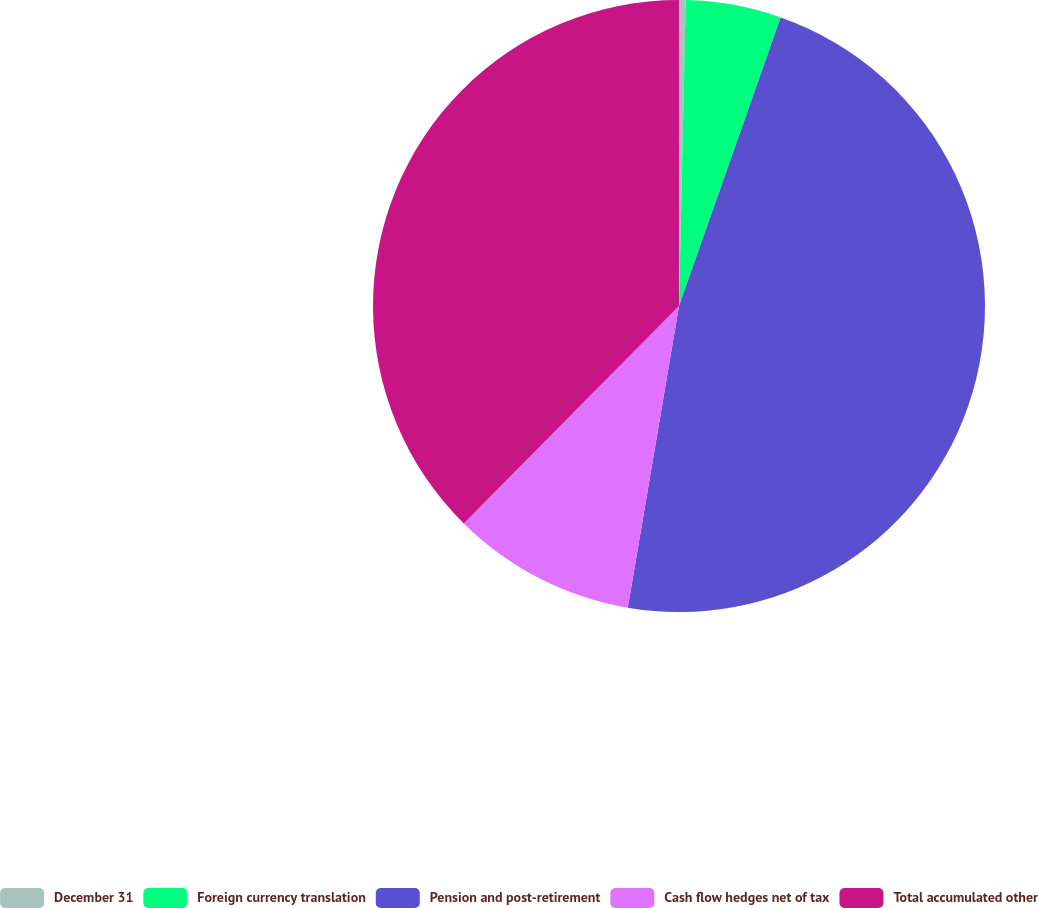Convert chart to OTSL. <chart><loc_0><loc_0><loc_500><loc_500><pie_chart><fcel>December 31<fcel>Foreign currency translation<fcel>Pension and post-retirement<fcel>Cash flow hedges net of tax<fcel>Total accumulated other<nl><fcel>0.35%<fcel>5.04%<fcel>47.28%<fcel>9.74%<fcel>37.58%<nl></chart> 